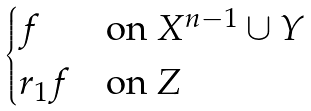Convert formula to latex. <formula><loc_0><loc_0><loc_500><loc_500>\begin{cases} f & \text {on $X^{n-1}\cup Y$} \\ r _ { 1 } f & \text {on $Z$} \end{cases}</formula> 